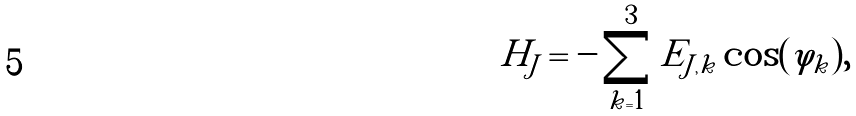Convert formula to latex. <formula><loc_0><loc_0><loc_500><loc_500>H _ { J } = - \sum _ { k = 1 } ^ { 3 } E _ { J , k } \cos ( \varphi _ { k } ) ,</formula> 